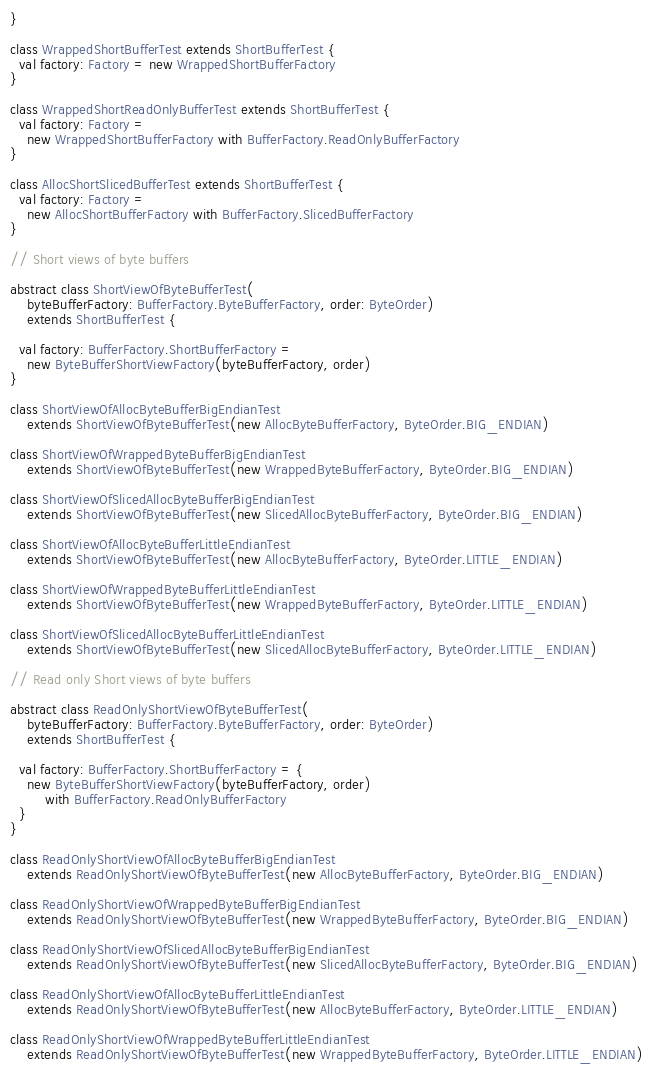<code> <loc_0><loc_0><loc_500><loc_500><_Scala_>}

class WrappedShortBufferTest extends ShortBufferTest {
  val factory: Factory = new WrappedShortBufferFactory
}

class WrappedShortReadOnlyBufferTest extends ShortBufferTest {
  val factory: Factory =
    new WrappedShortBufferFactory with BufferFactory.ReadOnlyBufferFactory
}

class AllocShortSlicedBufferTest extends ShortBufferTest {
  val factory: Factory =
    new AllocShortBufferFactory with BufferFactory.SlicedBufferFactory
}

// Short views of byte buffers

abstract class ShortViewOfByteBufferTest(
    byteBufferFactory: BufferFactory.ByteBufferFactory, order: ByteOrder)
    extends ShortBufferTest {

  val factory: BufferFactory.ShortBufferFactory =
    new ByteBufferShortViewFactory(byteBufferFactory, order)
}

class ShortViewOfAllocByteBufferBigEndianTest
    extends ShortViewOfByteBufferTest(new AllocByteBufferFactory, ByteOrder.BIG_ENDIAN)

class ShortViewOfWrappedByteBufferBigEndianTest
    extends ShortViewOfByteBufferTest(new WrappedByteBufferFactory, ByteOrder.BIG_ENDIAN)

class ShortViewOfSlicedAllocByteBufferBigEndianTest
    extends ShortViewOfByteBufferTest(new SlicedAllocByteBufferFactory, ByteOrder.BIG_ENDIAN)

class ShortViewOfAllocByteBufferLittleEndianTest
    extends ShortViewOfByteBufferTest(new AllocByteBufferFactory, ByteOrder.LITTLE_ENDIAN)

class ShortViewOfWrappedByteBufferLittleEndianTest
    extends ShortViewOfByteBufferTest(new WrappedByteBufferFactory, ByteOrder.LITTLE_ENDIAN)

class ShortViewOfSlicedAllocByteBufferLittleEndianTest
    extends ShortViewOfByteBufferTest(new SlicedAllocByteBufferFactory, ByteOrder.LITTLE_ENDIAN)

// Read only Short views of byte buffers

abstract class ReadOnlyShortViewOfByteBufferTest(
    byteBufferFactory: BufferFactory.ByteBufferFactory, order: ByteOrder)
    extends ShortBufferTest {

  val factory: BufferFactory.ShortBufferFactory = {
    new ByteBufferShortViewFactory(byteBufferFactory, order)
        with BufferFactory.ReadOnlyBufferFactory
  }
}

class ReadOnlyShortViewOfAllocByteBufferBigEndianTest
    extends ReadOnlyShortViewOfByteBufferTest(new AllocByteBufferFactory, ByteOrder.BIG_ENDIAN)

class ReadOnlyShortViewOfWrappedByteBufferBigEndianTest
    extends ReadOnlyShortViewOfByteBufferTest(new WrappedByteBufferFactory, ByteOrder.BIG_ENDIAN)

class ReadOnlyShortViewOfSlicedAllocByteBufferBigEndianTest
    extends ReadOnlyShortViewOfByteBufferTest(new SlicedAllocByteBufferFactory, ByteOrder.BIG_ENDIAN)

class ReadOnlyShortViewOfAllocByteBufferLittleEndianTest
    extends ReadOnlyShortViewOfByteBufferTest(new AllocByteBufferFactory, ByteOrder.LITTLE_ENDIAN)

class ReadOnlyShortViewOfWrappedByteBufferLittleEndianTest
    extends ReadOnlyShortViewOfByteBufferTest(new WrappedByteBufferFactory, ByteOrder.LITTLE_ENDIAN)
</code> 